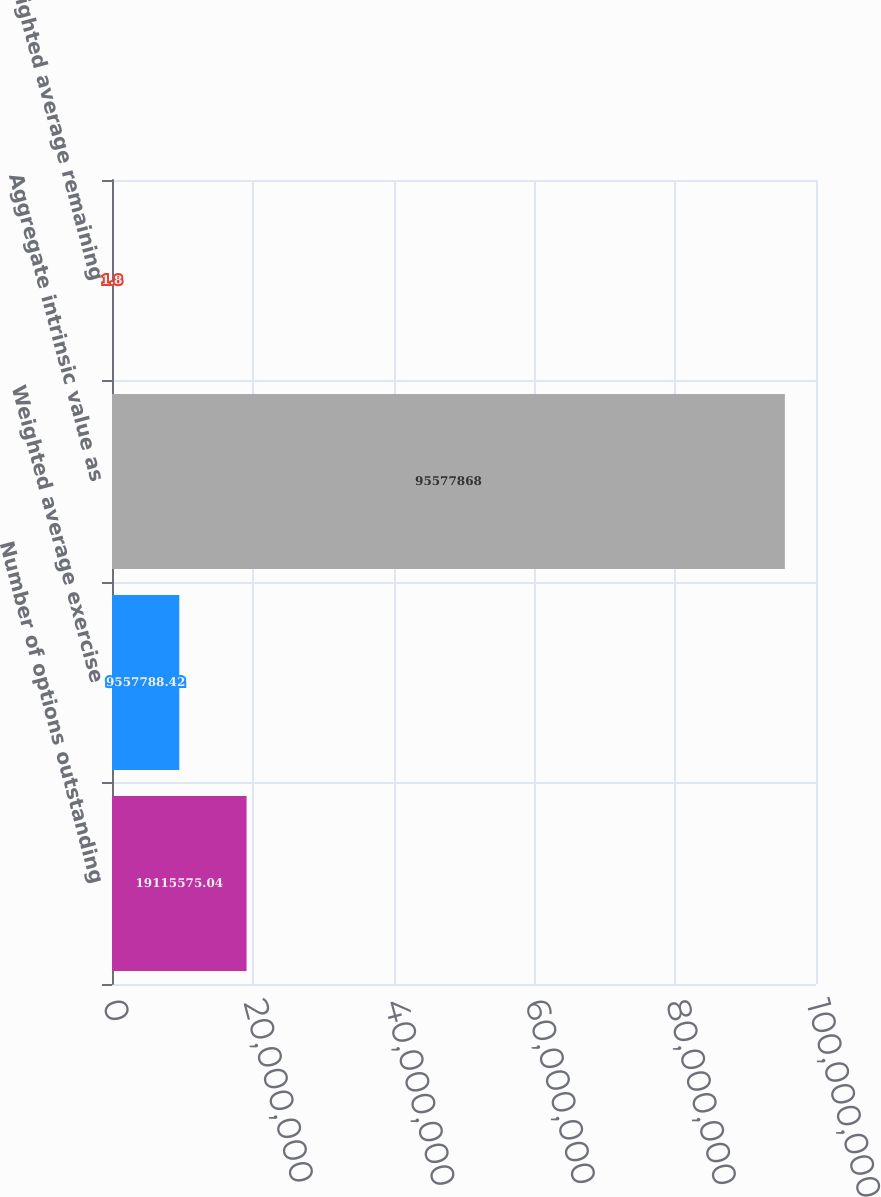Convert chart to OTSL. <chart><loc_0><loc_0><loc_500><loc_500><bar_chart><fcel>Number of options outstanding<fcel>Weighted average exercise<fcel>Aggregate intrinsic value as<fcel>Weighted average remaining<nl><fcel>1.91156e+07<fcel>9.55779e+06<fcel>9.55779e+07<fcel>1.8<nl></chart> 